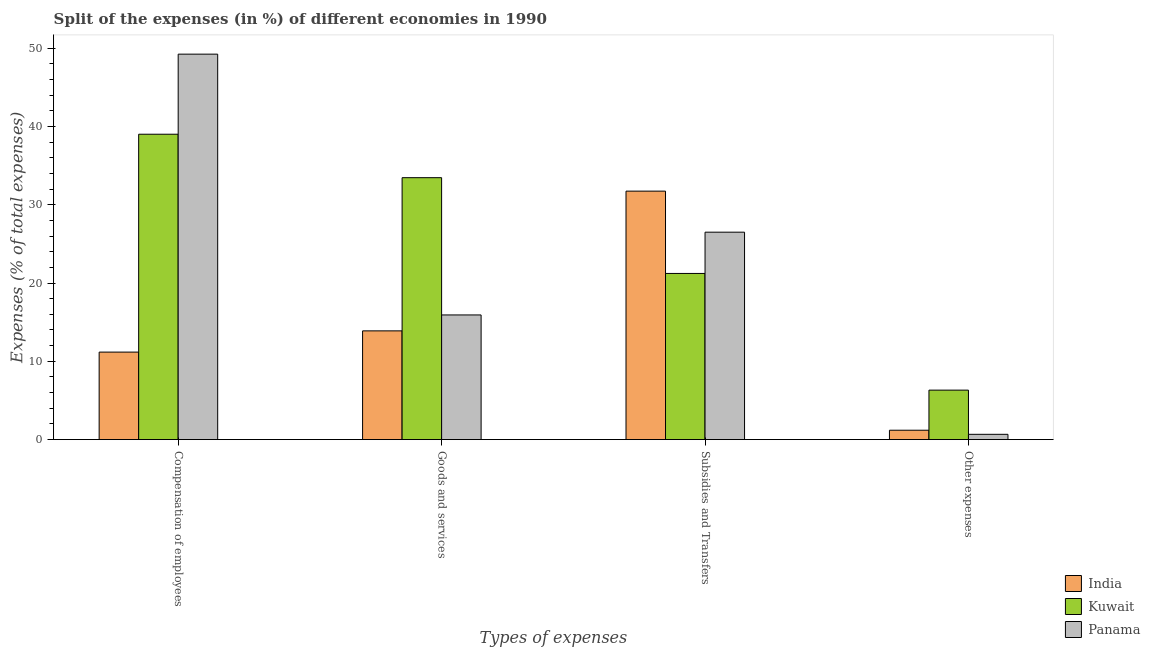How many different coloured bars are there?
Your response must be concise. 3. Are the number of bars on each tick of the X-axis equal?
Offer a terse response. Yes. How many bars are there on the 1st tick from the left?
Make the answer very short. 3. What is the label of the 4th group of bars from the left?
Offer a terse response. Other expenses. What is the percentage of amount spent on subsidies in Kuwait?
Provide a short and direct response. 21.22. Across all countries, what is the maximum percentage of amount spent on goods and services?
Your response must be concise. 33.45. Across all countries, what is the minimum percentage of amount spent on other expenses?
Your answer should be compact. 0.68. In which country was the percentage of amount spent on goods and services maximum?
Provide a short and direct response. Kuwait. In which country was the percentage of amount spent on other expenses minimum?
Your answer should be very brief. Panama. What is the total percentage of amount spent on subsidies in the graph?
Ensure brevity in your answer.  79.45. What is the difference between the percentage of amount spent on subsidies in India and that in Kuwait?
Make the answer very short. 10.51. What is the difference between the percentage of amount spent on other expenses in Panama and the percentage of amount spent on subsidies in Kuwait?
Provide a short and direct response. -20.55. What is the average percentage of amount spent on other expenses per country?
Ensure brevity in your answer.  2.73. What is the difference between the percentage of amount spent on compensation of employees and percentage of amount spent on goods and services in India?
Keep it short and to the point. -2.71. In how many countries, is the percentage of amount spent on goods and services greater than 6 %?
Your answer should be compact. 3. What is the ratio of the percentage of amount spent on other expenses in Panama to that in Kuwait?
Give a very brief answer. 0.11. What is the difference between the highest and the second highest percentage of amount spent on goods and services?
Your response must be concise. 17.53. What is the difference between the highest and the lowest percentage of amount spent on compensation of employees?
Provide a succinct answer. 38.06. In how many countries, is the percentage of amount spent on subsidies greater than the average percentage of amount spent on subsidies taken over all countries?
Ensure brevity in your answer.  2. Is it the case that in every country, the sum of the percentage of amount spent on other expenses and percentage of amount spent on goods and services is greater than the sum of percentage of amount spent on compensation of employees and percentage of amount spent on subsidies?
Make the answer very short. Yes. What does the 2nd bar from the left in Subsidies and Transfers represents?
Ensure brevity in your answer.  Kuwait. What does the 3rd bar from the right in Compensation of employees represents?
Provide a short and direct response. India. Is it the case that in every country, the sum of the percentage of amount spent on compensation of employees and percentage of amount spent on goods and services is greater than the percentage of amount spent on subsidies?
Offer a terse response. No. Are all the bars in the graph horizontal?
Keep it short and to the point. No. Does the graph contain any zero values?
Ensure brevity in your answer.  No. Where does the legend appear in the graph?
Offer a very short reply. Bottom right. How many legend labels are there?
Offer a very short reply. 3. What is the title of the graph?
Your answer should be compact. Split of the expenses (in %) of different economies in 1990. Does "Indonesia" appear as one of the legend labels in the graph?
Offer a very short reply. No. What is the label or title of the X-axis?
Your answer should be very brief. Types of expenses. What is the label or title of the Y-axis?
Ensure brevity in your answer.  Expenses (% of total expenses). What is the Expenses (% of total expenses) of India in Compensation of employees?
Keep it short and to the point. 11.18. What is the Expenses (% of total expenses) of Kuwait in Compensation of employees?
Your answer should be very brief. 39. What is the Expenses (% of total expenses) in Panama in Compensation of employees?
Provide a succinct answer. 49.23. What is the Expenses (% of total expenses) of India in Goods and services?
Give a very brief answer. 13.89. What is the Expenses (% of total expenses) of Kuwait in Goods and services?
Provide a short and direct response. 33.45. What is the Expenses (% of total expenses) in Panama in Goods and services?
Provide a short and direct response. 15.92. What is the Expenses (% of total expenses) in India in Subsidies and Transfers?
Your answer should be very brief. 31.74. What is the Expenses (% of total expenses) in Kuwait in Subsidies and Transfers?
Your answer should be very brief. 21.22. What is the Expenses (% of total expenses) of Panama in Subsidies and Transfers?
Provide a succinct answer. 26.49. What is the Expenses (% of total expenses) in India in Other expenses?
Offer a very short reply. 1.2. What is the Expenses (% of total expenses) of Kuwait in Other expenses?
Provide a succinct answer. 6.32. What is the Expenses (% of total expenses) in Panama in Other expenses?
Your response must be concise. 0.68. Across all Types of expenses, what is the maximum Expenses (% of total expenses) in India?
Provide a short and direct response. 31.74. Across all Types of expenses, what is the maximum Expenses (% of total expenses) in Kuwait?
Your response must be concise. 39. Across all Types of expenses, what is the maximum Expenses (% of total expenses) of Panama?
Your answer should be very brief. 49.23. Across all Types of expenses, what is the minimum Expenses (% of total expenses) in India?
Provide a short and direct response. 1.2. Across all Types of expenses, what is the minimum Expenses (% of total expenses) in Kuwait?
Keep it short and to the point. 6.32. Across all Types of expenses, what is the minimum Expenses (% of total expenses) in Panama?
Offer a terse response. 0.68. What is the total Expenses (% of total expenses) in India in the graph?
Offer a terse response. 58. What is the total Expenses (% of total expenses) in Panama in the graph?
Offer a terse response. 92.32. What is the difference between the Expenses (% of total expenses) in India in Compensation of employees and that in Goods and services?
Offer a very short reply. -2.71. What is the difference between the Expenses (% of total expenses) in Kuwait in Compensation of employees and that in Goods and services?
Give a very brief answer. 5.55. What is the difference between the Expenses (% of total expenses) in Panama in Compensation of employees and that in Goods and services?
Provide a succinct answer. 33.31. What is the difference between the Expenses (% of total expenses) of India in Compensation of employees and that in Subsidies and Transfers?
Provide a short and direct response. -20.56. What is the difference between the Expenses (% of total expenses) in Kuwait in Compensation of employees and that in Subsidies and Transfers?
Ensure brevity in your answer.  17.78. What is the difference between the Expenses (% of total expenses) of Panama in Compensation of employees and that in Subsidies and Transfers?
Give a very brief answer. 22.74. What is the difference between the Expenses (% of total expenses) in India in Compensation of employees and that in Other expenses?
Provide a succinct answer. 9.98. What is the difference between the Expenses (% of total expenses) in Kuwait in Compensation of employees and that in Other expenses?
Provide a succinct answer. 32.69. What is the difference between the Expenses (% of total expenses) of Panama in Compensation of employees and that in Other expenses?
Offer a very short reply. 48.56. What is the difference between the Expenses (% of total expenses) of India in Goods and services and that in Subsidies and Transfers?
Provide a short and direct response. -17.85. What is the difference between the Expenses (% of total expenses) of Kuwait in Goods and services and that in Subsidies and Transfers?
Offer a terse response. 12.23. What is the difference between the Expenses (% of total expenses) of Panama in Goods and services and that in Subsidies and Transfers?
Offer a very short reply. -10.57. What is the difference between the Expenses (% of total expenses) in India in Goods and services and that in Other expenses?
Provide a short and direct response. 12.69. What is the difference between the Expenses (% of total expenses) in Kuwait in Goods and services and that in Other expenses?
Provide a short and direct response. 27.14. What is the difference between the Expenses (% of total expenses) of Panama in Goods and services and that in Other expenses?
Make the answer very short. 15.25. What is the difference between the Expenses (% of total expenses) of India in Subsidies and Transfers and that in Other expenses?
Give a very brief answer. 30.54. What is the difference between the Expenses (% of total expenses) in Kuwait in Subsidies and Transfers and that in Other expenses?
Provide a short and direct response. 14.9. What is the difference between the Expenses (% of total expenses) of Panama in Subsidies and Transfers and that in Other expenses?
Provide a short and direct response. 25.82. What is the difference between the Expenses (% of total expenses) in India in Compensation of employees and the Expenses (% of total expenses) in Kuwait in Goods and services?
Your response must be concise. -22.28. What is the difference between the Expenses (% of total expenses) of India in Compensation of employees and the Expenses (% of total expenses) of Panama in Goods and services?
Give a very brief answer. -4.75. What is the difference between the Expenses (% of total expenses) in Kuwait in Compensation of employees and the Expenses (% of total expenses) in Panama in Goods and services?
Keep it short and to the point. 23.08. What is the difference between the Expenses (% of total expenses) in India in Compensation of employees and the Expenses (% of total expenses) in Kuwait in Subsidies and Transfers?
Provide a short and direct response. -10.05. What is the difference between the Expenses (% of total expenses) of India in Compensation of employees and the Expenses (% of total expenses) of Panama in Subsidies and Transfers?
Your answer should be very brief. -15.32. What is the difference between the Expenses (% of total expenses) of Kuwait in Compensation of employees and the Expenses (% of total expenses) of Panama in Subsidies and Transfers?
Give a very brief answer. 12.51. What is the difference between the Expenses (% of total expenses) of India in Compensation of employees and the Expenses (% of total expenses) of Kuwait in Other expenses?
Ensure brevity in your answer.  4.86. What is the difference between the Expenses (% of total expenses) in India in Compensation of employees and the Expenses (% of total expenses) in Panama in Other expenses?
Your response must be concise. 10.5. What is the difference between the Expenses (% of total expenses) in Kuwait in Compensation of employees and the Expenses (% of total expenses) in Panama in Other expenses?
Ensure brevity in your answer.  38.33. What is the difference between the Expenses (% of total expenses) in India in Goods and services and the Expenses (% of total expenses) in Kuwait in Subsidies and Transfers?
Offer a terse response. -7.34. What is the difference between the Expenses (% of total expenses) of India in Goods and services and the Expenses (% of total expenses) of Panama in Subsidies and Transfers?
Make the answer very short. -12.61. What is the difference between the Expenses (% of total expenses) of Kuwait in Goods and services and the Expenses (% of total expenses) of Panama in Subsidies and Transfers?
Your response must be concise. 6.96. What is the difference between the Expenses (% of total expenses) in India in Goods and services and the Expenses (% of total expenses) in Kuwait in Other expenses?
Your response must be concise. 7.57. What is the difference between the Expenses (% of total expenses) of India in Goods and services and the Expenses (% of total expenses) of Panama in Other expenses?
Make the answer very short. 13.21. What is the difference between the Expenses (% of total expenses) of Kuwait in Goods and services and the Expenses (% of total expenses) of Panama in Other expenses?
Offer a terse response. 32.78. What is the difference between the Expenses (% of total expenses) of India in Subsidies and Transfers and the Expenses (% of total expenses) of Kuwait in Other expenses?
Provide a short and direct response. 25.42. What is the difference between the Expenses (% of total expenses) of India in Subsidies and Transfers and the Expenses (% of total expenses) of Panama in Other expenses?
Make the answer very short. 31.06. What is the difference between the Expenses (% of total expenses) of Kuwait in Subsidies and Transfers and the Expenses (% of total expenses) of Panama in Other expenses?
Provide a succinct answer. 20.55. What is the average Expenses (% of total expenses) in India per Types of expenses?
Give a very brief answer. 14.5. What is the average Expenses (% of total expenses) of Panama per Types of expenses?
Offer a very short reply. 23.08. What is the difference between the Expenses (% of total expenses) of India and Expenses (% of total expenses) of Kuwait in Compensation of employees?
Offer a very short reply. -27.83. What is the difference between the Expenses (% of total expenses) in India and Expenses (% of total expenses) in Panama in Compensation of employees?
Offer a very short reply. -38.06. What is the difference between the Expenses (% of total expenses) of Kuwait and Expenses (% of total expenses) of Panama in Compensation of employees?
Keep it short and to the point. -10.23. What is the difference between the Expenses (% of total expenses) of India and Expenses (% of total expenses) of Kuwait in Goods and services?
Provide a short and direct response. -19.57. What is the difference between the Expenses (% of total expenses) of India and Expenses (% of total expenses) of Panama in Goods and services?
Provide a succinct answer. -2.04. What is the difference between the Expenses (% of total expenses) of Kuwait and Expenses (% of total expenses) of Panama in Goods and services?
Offer a very short reply. 17.53. What is the difference between the Expenses (% of total expenses) in India and Expenses (% of total expenses) in Kuwait in Subsidies and Transfers?
Keep it short and to the point. 10.51. What is the difference between the Expenses (% of total expenses) of India and Expenses (% of total expenses) of Panama in Subsidies and Transfers?
Offer a terse response. 5.24. What is the difference between the Expenses (% of total expenses) of Kuwait and Expenses (% of total expenses) of Panama in Subsidies and Transfers?
Give a very brief answer. -5.27. What is the difference between the Expenses (% of total expenses) of India and Expenses (% of total expenses) of Kuwait in Other expenses?
Keep it short and to the point. -5.12. What is the difference between the Expenses (% of total expenses) of India and Expenses (% of total expenses) of Panama in Other expenses?
Ensure brevity in your answer.  0.52. What is the difference between the Expenses (% of total expenses) in Kuwait and Expenses (% of total expenses) in Panama in Other expenses?
Provide a short and direct response. 5.64. What is the ratio of the Expenses (% of total expenses) of India in Compensation of employees to that in Goods and services?
Provide a succinct answer. 0.8. What is the ratio of the Expenses (% of total expenses) in Kuwait in Compensation of employees to that in Goods and services?
Your answer should be compact. 1.17. What is the ratio of the Expenses (% of total expenses) in Panama in Compensation of employees to that in Goods and services?
Ensure brevity in your answer.  3.09. What is the ratio of the Expenses (% of total expenses) in India in Compensation of employees to that in Subsidies and Transfers?
Provide a succinct answer. 0.35. What is the ratio of the Expenses (% of total expenses) in Kuwait in Compensation of employees to that in Subsidies and Transfers?
Offer a terse response. 1.84. What is the ratio of the Expenses (% of total expenses) in Panama in Compensation of employees to that in Subsidies and Transfers?
Make the answer very short. 1.86. What is the ratio of the Expenses (% of total expenses) of India in Compensation of employees to that in Other expenses?
Offer a terse response. 9.34. What is the ratio of the Expenses (% of total expenses) of Kuwait in Compensation of employees to that in Other expenses?
Your answer should be compact. 6.17. What is the ratio of the Expenses (% of total expenses) of Panama in Compensation of employees to that in Other expenses?
Your answer should be compact. 72.92. What is the ratio of the Expenses (% of total expenses) in India in Goods and services to that in Subsidies and Transfers?
Keep it short and to the point. 0.44. What is the ratio of the Expenses (% of total expenses) in Kuwait in Goods and services to that in Subsidies and Transfers?
Your response must be concise. 1.58. What is the ratio of the Expenses (% of total expenses) in Panama in Goods and services to that in Subsidies and Transfers?
Keep it short and to the point. 0.6. What is the ratio of the Expenses (% of total expenses) of India in Goods and services to that in Other expenses?
Provide a short and direct response. 11.6. What is the ratio of the Expenses (% of total expenses) in Kuwait in Goods and services to that in Other expenses?
Your answer should be compact. 5.29. What is the ratio of the Expenses (% of total expenses) in Panama in Goods and services to that in Other expenses?
Offer a very short reply. 23.58. What is the ratio of the Expenses (% of total expenses) of India in Subsidies and Transfers to that in Other expenses?
Your response must be concise. 26.51. What is the ratio of the Expenses (% of total expenses) in Kuwait in Subsidies and Transfers to that in Other expenses?
Give a very brief answer. 3.36. What is the ratio of the Expenses (% of total expenses) in Panama in Subsidies and Transfers to that in Other expenses?
Give a very brief answer. 39.24. What is the difference between the highest and the second highest Expenses (% of total expenses) in India?
Your answer should be very brief. 17.85. What is the difference between the highest and the second highest Expenses (% of total expenses) in Kuwait?
Offer a terse response. 5.55. What is the difference between the highest and the second highest Expenses (% of total expenses) of Panama?
Your answer should be compact. 22.74. What is the difference between the highest and the lowest Expenses (% of total expenses) in India?
Your response must be concise. 30.54. What is the difference between the highest and the lowest Expenses (% of total expenses) of Kuwait?
Keep it short and to the point. 32.69. What is the difference between the highest and the lowest Expenses (% of total expenses) of Panama?
Keep it short and to the point. 48.56. 